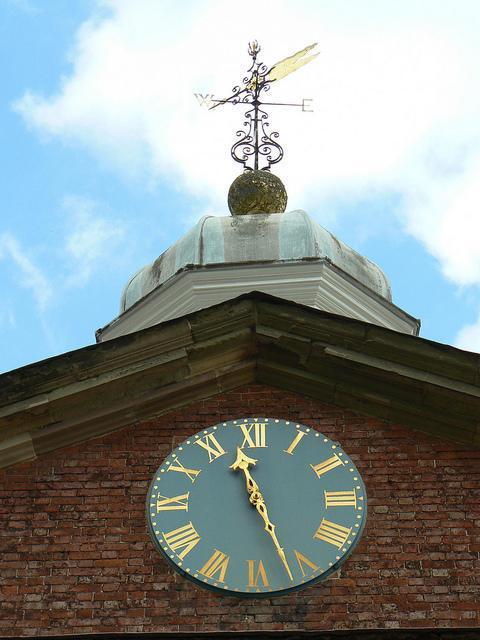How many clocks are there?
Give a very brief answer. 1. How many people are wearing white shirts?
Give a very brief answer. 0. 